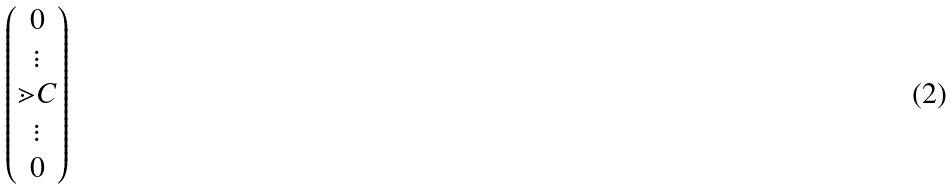Convert formula to latex. <formula><loc_0><loc_0><loc_500><loc_500>\begin{pmatrix} 0 \\ \vdots \\ \mathbb { m } { C } \\ \vdots \\ 0 \end{pmatrix}</formula> 